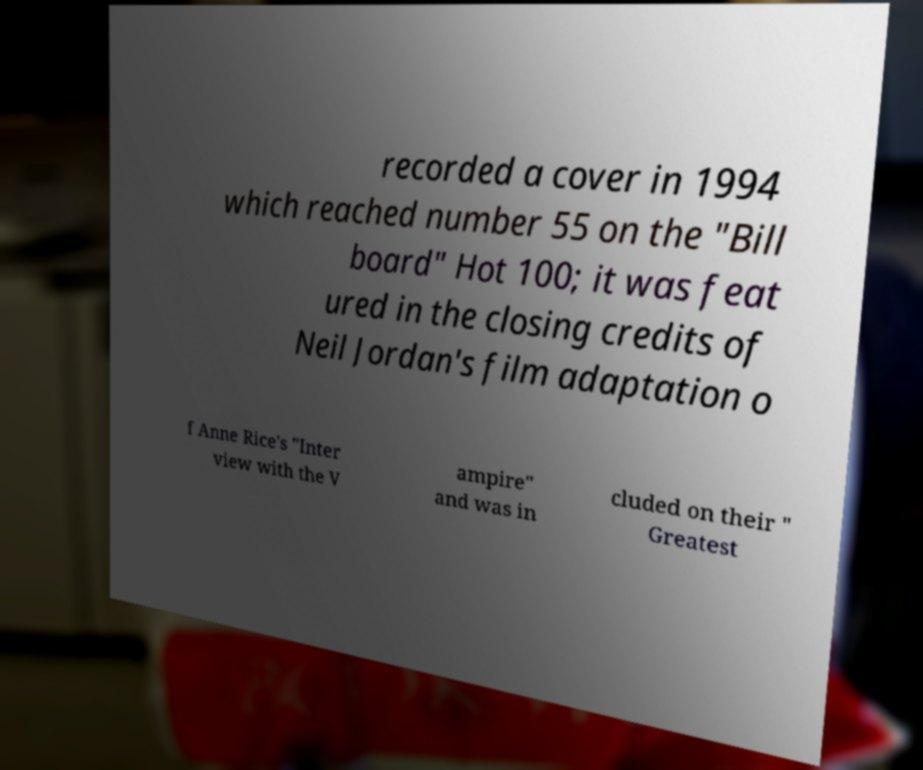What messages or text are displayed in this image? I need them in a readable, typed format. recorded a cover in 1994 which reached number 55 on the "Bill board" Hot 100; it was feat ured in the closing credits of Neil Jordan's film adaptation o f Anne Rice's "Inter view with the V ampire" and was in cluded on their " Greatest 